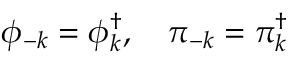<formula> <loc_0><loc_0><loc_500><loc_500>\phi _ { - k } = \phi _ { k } ^ { \dagger } , \pi _ { - k } = \pi _ { k } ^ { \dagger }</formula> 